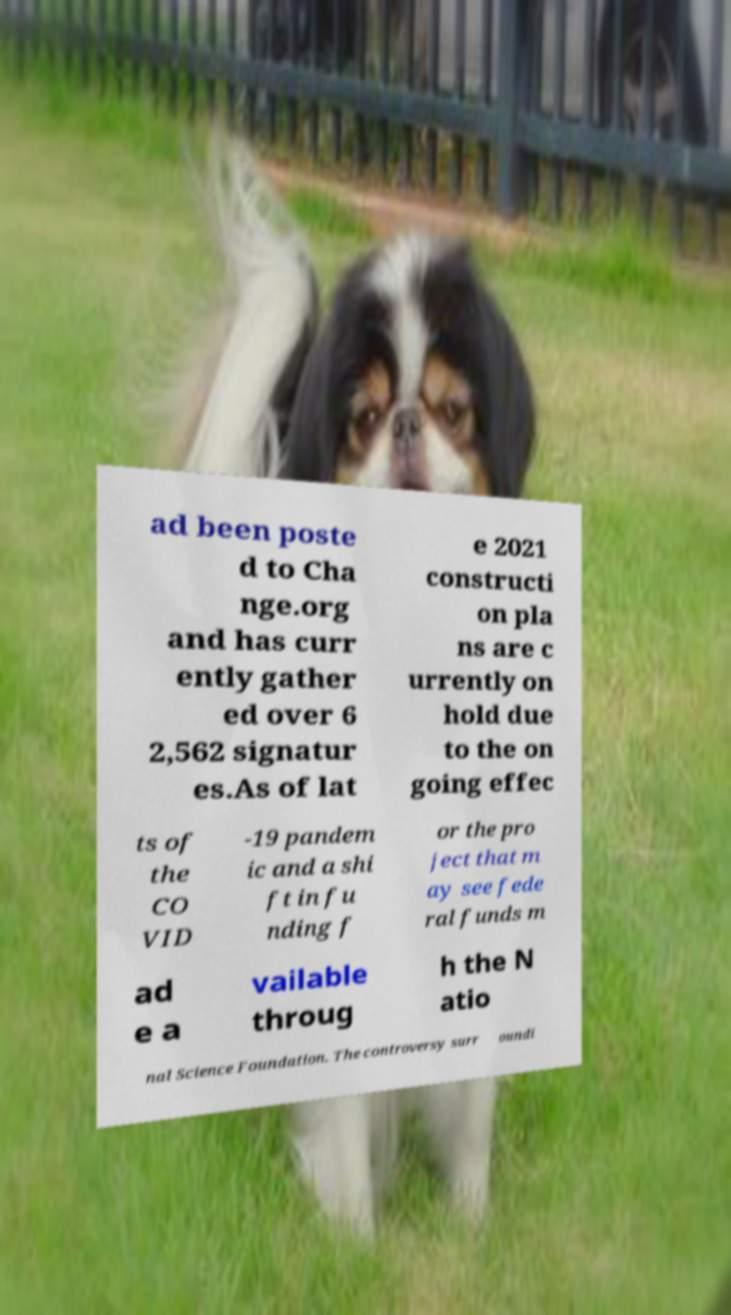Could you assist in decoding the text presented in this image and type it out clearly? ad been poste d to Cha nge.org and has curr ently gather ed over 6 2,562 signatur es.As of lat e 2021 constructi on pla ns are c urrently on hold due to the on going effec ts of the CO VID -19 pandem ic and a shi ft in fu nding f or the pro ject that m ay see fede ral funds m ad e a vailable throug h the N atio nal Science Foundation. The controversy surr oundi 